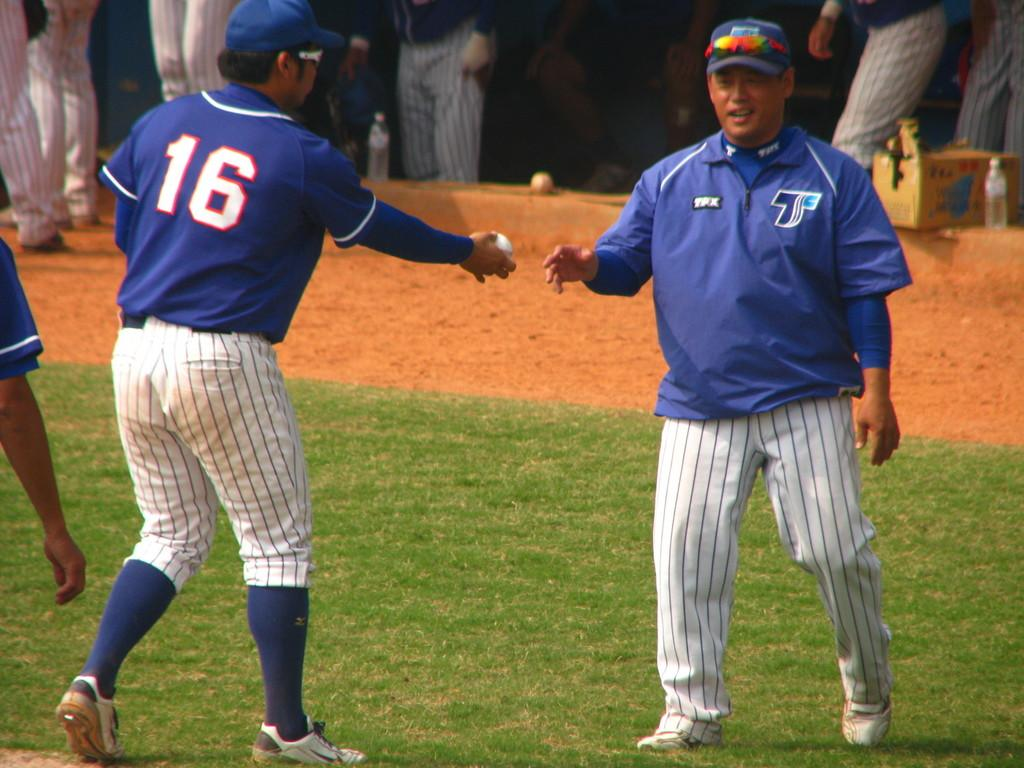Provide a one-sentence caption for the provided image. a man with the letter T on the side of his jacket. 